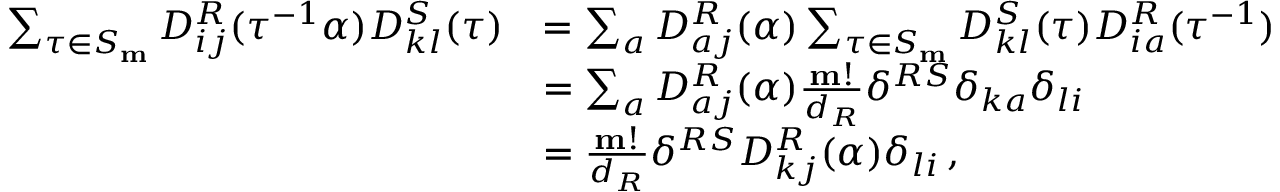<formula> <loc_0><loc_0><loc_500><loc_500>\begin{array} { r l } { \sum _ { \tau \in S _ { m } } D _ { i j } ^ { R } ( \tau ^ { - 1 } \alpha ) D _ { k l } ^ { S } ( \tau ) } & { = \sum _ { a } D _ { a j } ^ { R } ( \alpha ) \sum _ { \tau \in S _ { m } } D _ { k l } ^ { S } ( \tau ) D _ { i a } ^ { R } ( \tau ^ { - 1 } ) } \\ & { = \sum _ { a } D _ { a j } ^ { R } ( \alpha ) \frac { m ! } { d _ { R } } \delta ^ { R S } \delta _ { k a } \delta _ { l i } } \\ & { = \frac { m ! } { d _ { R } } \delta ^ { R S } D _ { k j } ^ { R } ( \alpha ) \delta _ { l i } \, , } \end{array}</formula> 